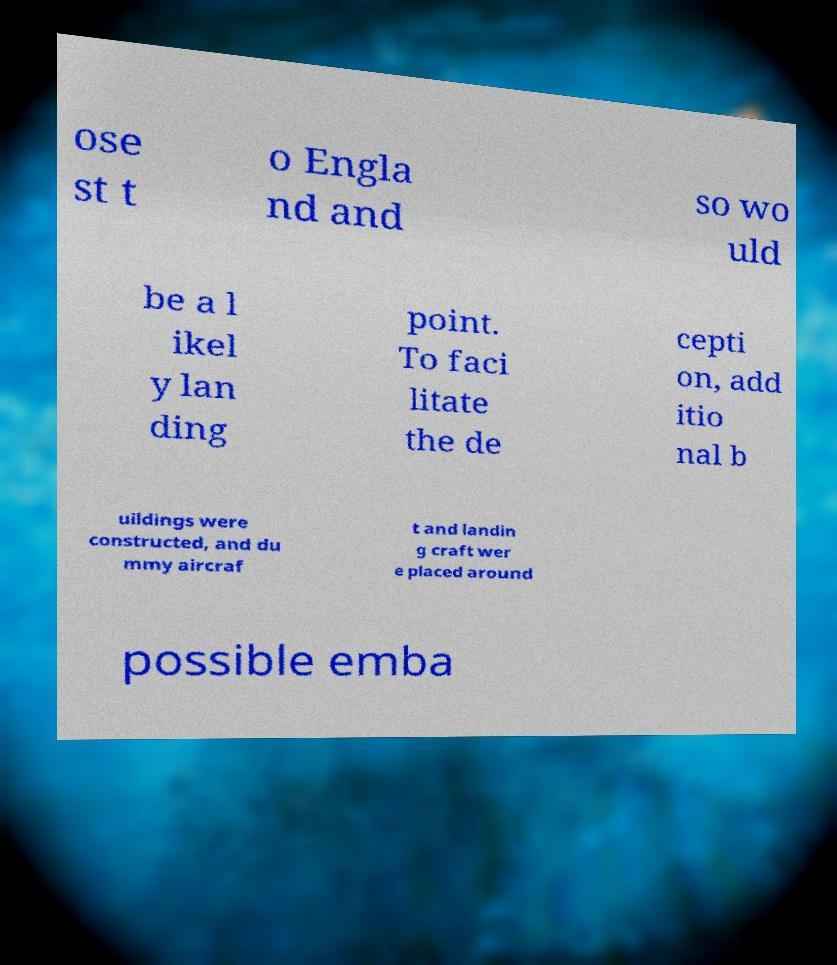What messages or text are displayed in this image? I need them in a readable, typed format. ose st t o Engla nd and so wo uld be a l ikel y lan ding point. To faci litate the de cepti on, add itio nal b uildings were constructed, and du mmy aircraf t and landin g craft wer e placed around possible emba 